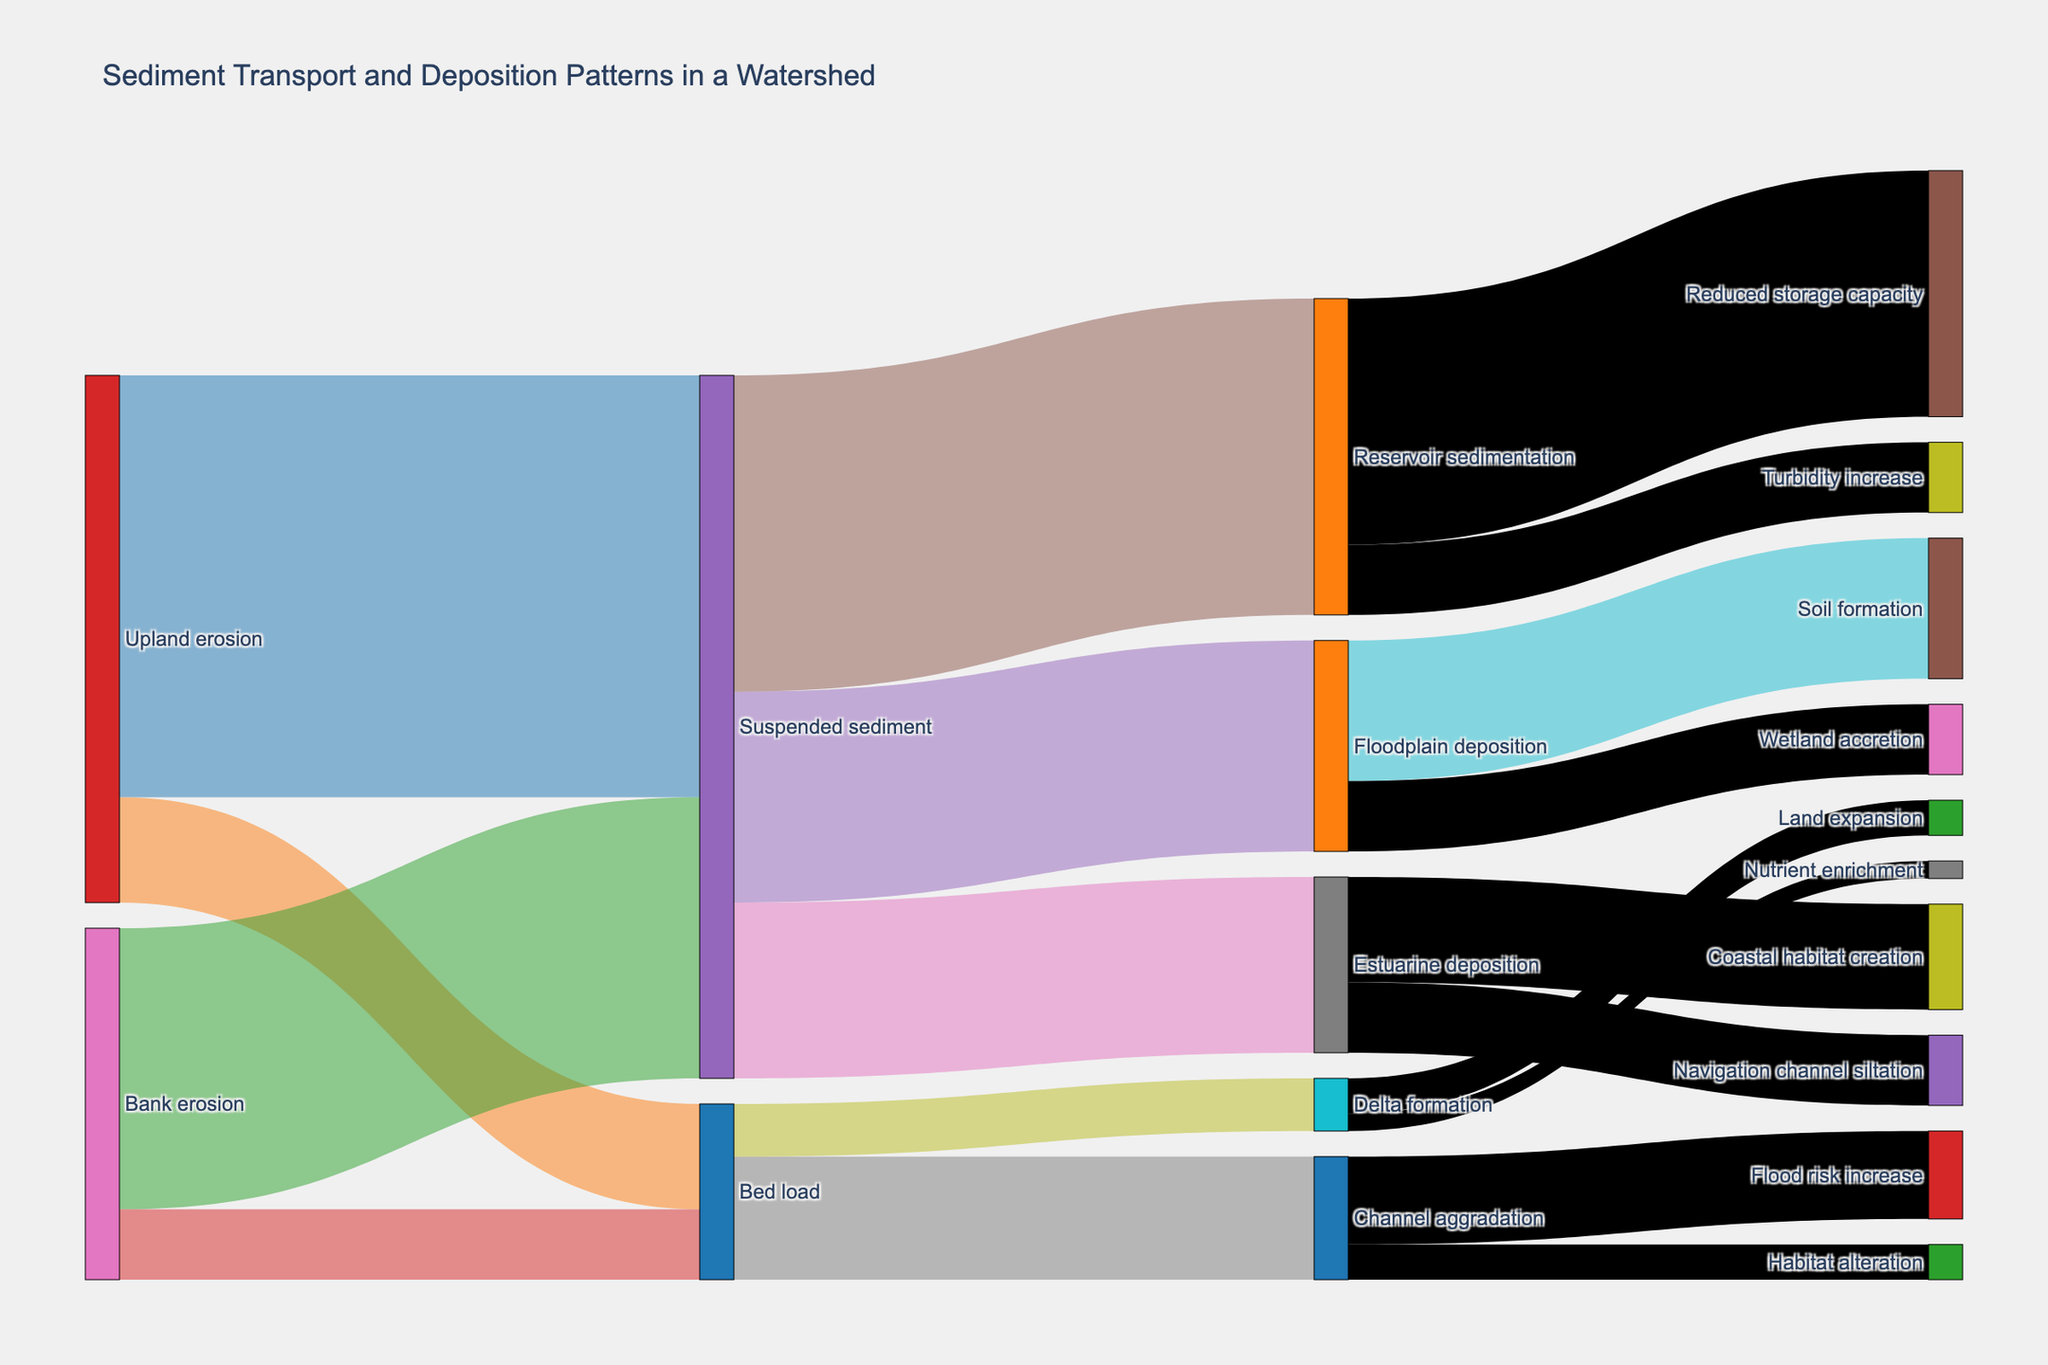What is the title of the Sankey diagram? The title is typically found at the top of the figure and it provides an overview of what the diagram is about.
Answer: Sediment Transport and Deposition Patterns in a Watershed Which node is associated with the highest initial sediment contribution? To determine this, look at the values associated with each source node. The node with the highest combined value represents the largest initial contribution.
Answer: Upland erosion How much sediment does Floodplain deposition receive in total? To find this, add up the value of sediments going to Floodplain deposition. Specifically, it receives 600 from Suspended sediment.
Answer: 600 What is the combined sediment value that Suspended sediment transports to its three target nodes? Sum the values of sediment going from Suspended sediment to Floodplain deposition (600), Reservoir sedimentation (900), and Estuarine deposition (500). So the total is 600 + 900 + 500.
Answer: 2000 Which node receives the least amount of sediment from Bed load? Observe the values of sediment flow from Bed load to its targets and select the one with the smallest value. The values are Channel aggradation (350) and Delta formation (150). The least is Delta formation.
Answer: Delta formation How does the sediment value transported to Coastal habitat creation compare with that transported to Land expansion? Compare the values directly. Coastal habitat creation receives 300 from Estuarine deposition, while Land expansion receives 100 from Delta formation.
Answer: Greater What is the total sediment contributed by Bank erosion? Sum the values of sediments contributed from Bank erosion: 800 to Suspended sediment and 200 to Bed load. Therefore, the total is 800 + 200.
Answer: 1000 Which two processes lead to Soil formation and Wetland accretion within Floodplain deposition? Check the target nodes under Floodplain deposition. Part of its sediment goes to Soil formation (400) and Wetland accretion (200).
Answer: Soil formation and Wetland accretion What effect is associated with the highest value linked to Reservoir sedimentation? Observe the effects of Reservoir sedimentation. The values associated include Reduced storage capacity (700) and Turbidity increase (200). Reduced storage capacity has the highest value.
Answer: Reduced storage capacity What total value of sediment contributes to Habitat alteration? Since Habitat alteration is linked to Channel aggradation, look at the total value for Channel aggradation. The value is 100.
Answer: 100 